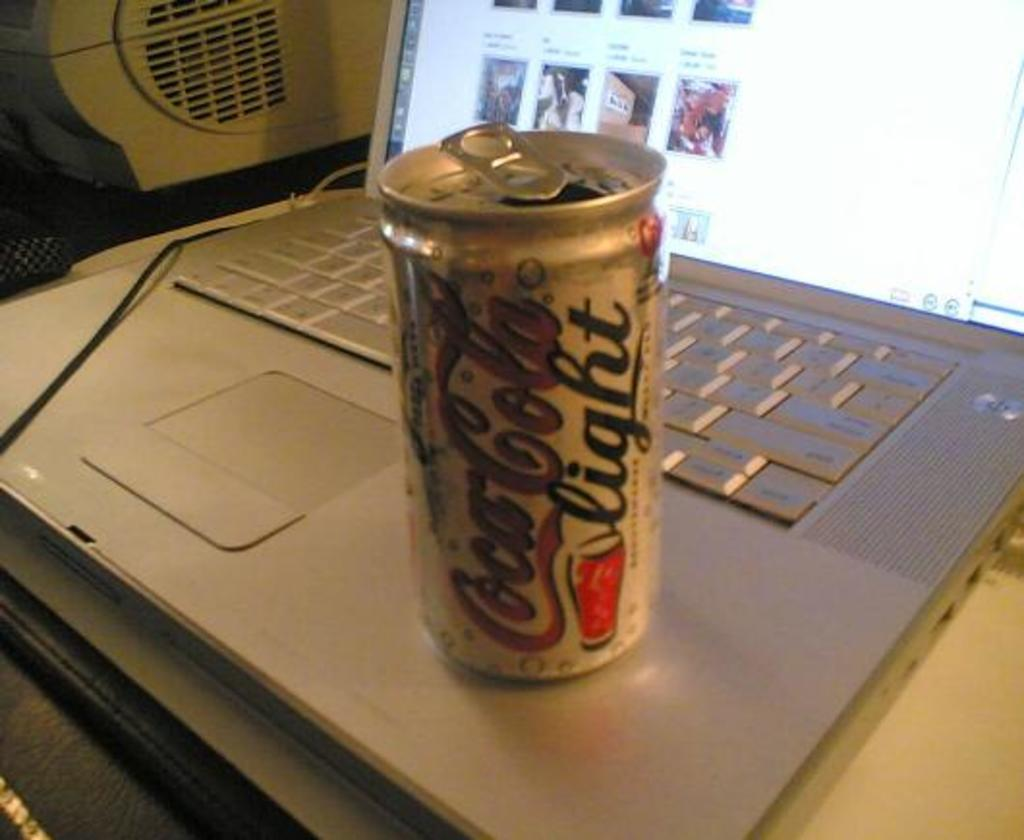<image>
Share a concise interpretation of the image provided. A can of Coca Cola light sits on a laptop. 